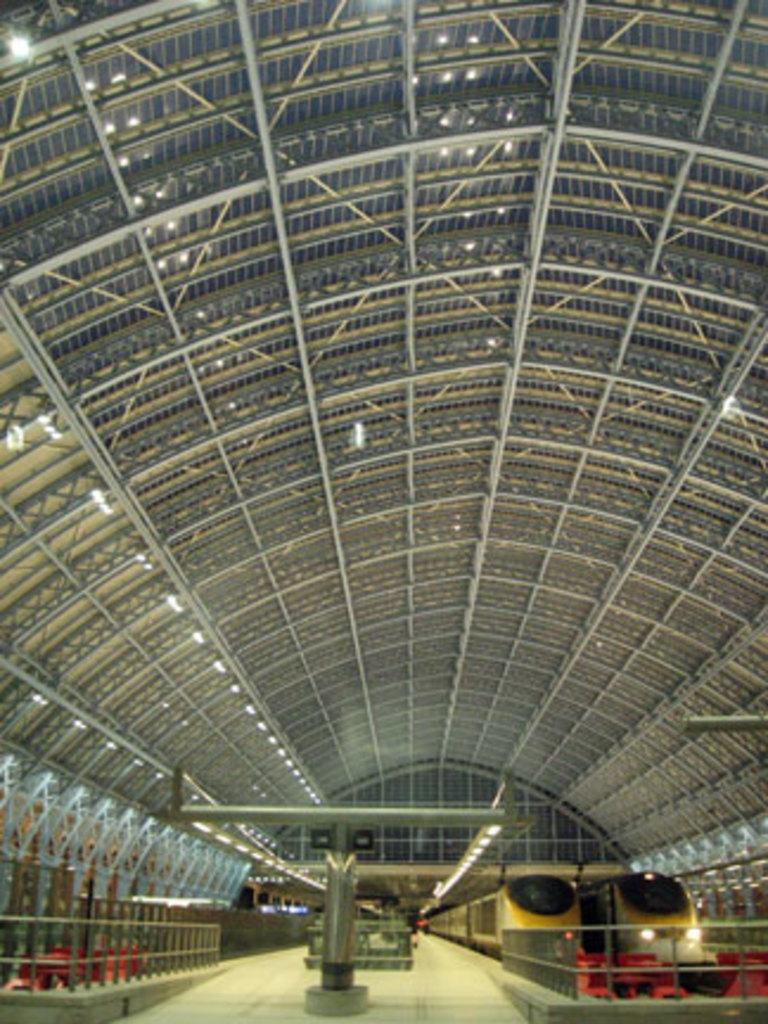What type of vehicles can be seen in the bottom right corner of the image? There are two trains in the bottom right corner of the image. What is the main feature visible in the middle of the image? There is a big hall visible in the middle of the image. What type of offer is being made by the baby in the image? There is no baby present in the image, so no offer can be made by a baby. What unit of measurement is used to describe the size of the hall in the image? The provided facts do not mention any specific unit of measurement for the size of the hall, so it cannot be determined from the image. 